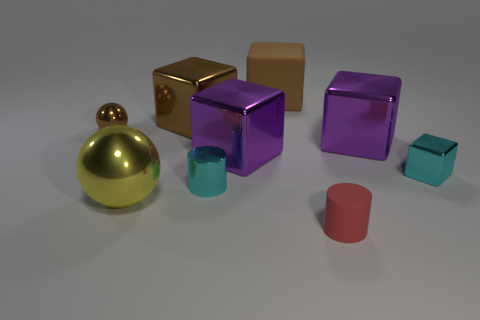Taking into account their sizes, which objects might weigh more and why? Assuming the objects are made from materials with similar densities, the yellow cube and the larger purple cube would likely weigh more due to their size. The volume of an object is a significant factor in its weight when material density is constant, and these two objects have a greater volume compared to the others. 